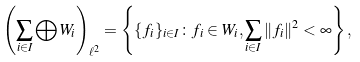<formula> <loc_0><loc_0><loc_500><loc_500>\left ( \sum _ { i \in I } \bigoplus W _ { i } \right ) _ { \ell ^ { 2 } } = \left \{ \{ f _ { i } \} _ { i \in I } \colon f _ { i } \in W _ { i } , \sum _ { i \in I } \| f _ { i } \| ^ { 2 } < \infty \right \} ,</formula> 